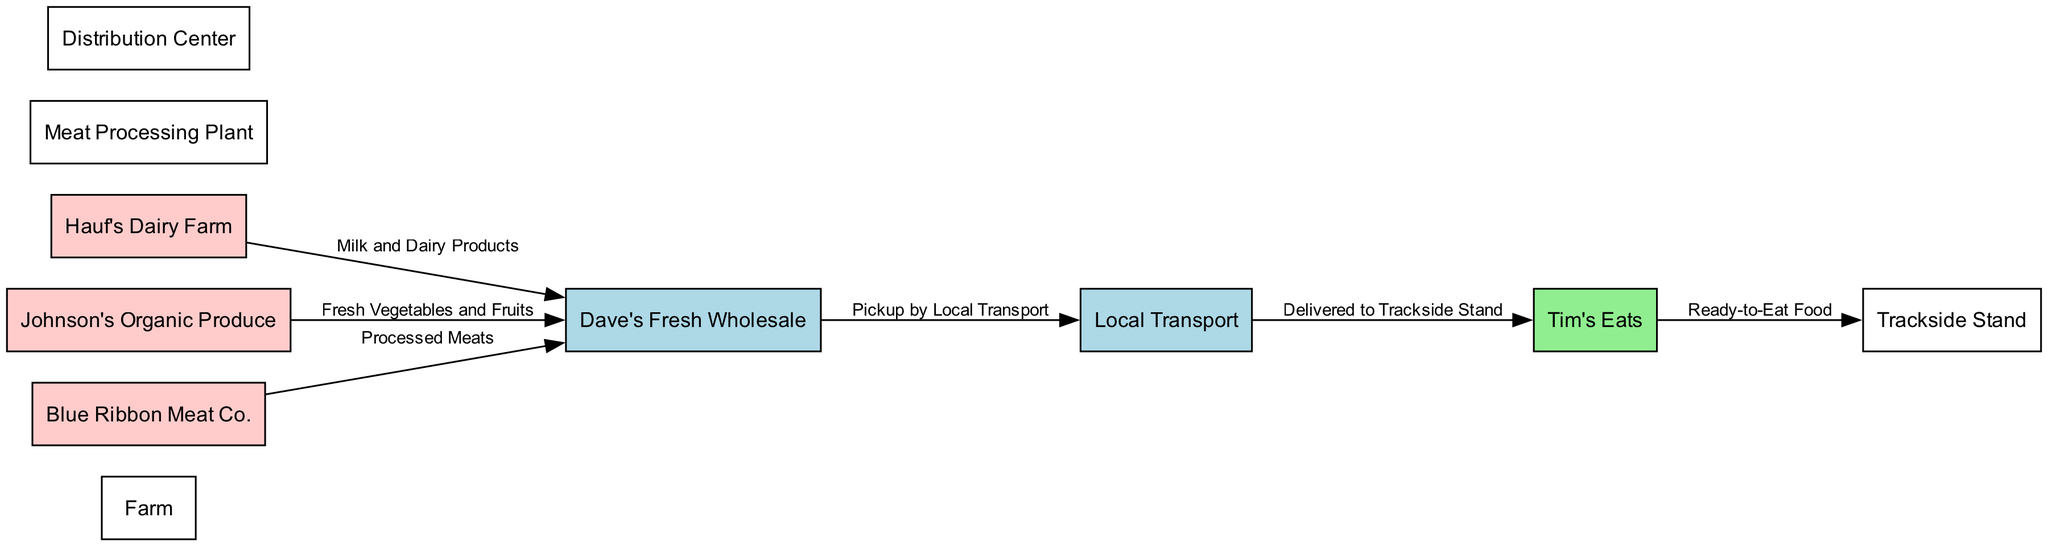What is the first node in the supply chain? The first node in the diagram is "Farm," which represents the starting point for all products in the food supply chain.
Answer: Farm How many suppliers are in the food supply chain? There are three suppliers in the diagram: Hauf's Dairy Farm, Johnson's Organic Produce, and Blue Ribbon Meat Co. The count is derived from identifying nodes labeled as suppliers.
Answer: 3 What type of products does Hauf's Dairy Farm supply? Hauf's Dairy Farm supplies "Milk and Dairy Products," which is indicated by the edge label connecting it to the distribution center.
Answer: Milk and Dairy Products Which node receives the processed meats? The node that receives processed meats is "Dave's Fresh Wholesale," as indicated by the edge from Blue Ribbon Meat Co. labeled with "Processed Meats."
Answer: Dave's Fresh Wholesale What is the final product delivered to the trackside stand? The final product delivered to the trackside stand is "Ready-to-Eat Food," according to the last edge connecting Tim's Eats to Trackside Stand.
Answer: Ready-to-Eat Food Which node represents local transport in the supply chain? The node representing local transport is "Local Transport," identified by its specific label and position in the sequence of the diagram connecting products between distribution and trackside.
Answer: Local Transport What are the two types of products that are supplied to Dave's Fresh Wholesale? The two types of products supplied to Dave's Fresh Wholesale are "Milk and Dairy Products" from Hauf's Dairy Farm and "Fresh Vegetables and Fruits" from Johnson's Organic Produce, as seen in the edges leading to it.
Answer: Milk and Dairy Products, Fresh Vegetables and Fruits Which node is responsible for the final selling of food products at the event? The node responsible for the final selling of food products is "Trackside Stand," as it represents the location where food is actually sold to event attendees.
Answer: Trackside Stand How are the products transported to Tim's Eats? The products are transported to Tim's Eats via "Delivered to Trackside Stand," which is shown by the directed edge from Local Transport to Tim's Eats.
Answer: Delivered to Trackside Stand 